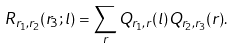Convert formula to latex. <formula><loc_0><loc_0><loc_500><loc_500>R _ { r _ { 1 } , r _ { 2 } } ( r _ { 3 } ; l ) = \sum _ { r } Q _ { r _ { 1 } , r } ( l ) Q _ { r _ { 2 } , r _ { 3 } } ( r ) .</formula> 